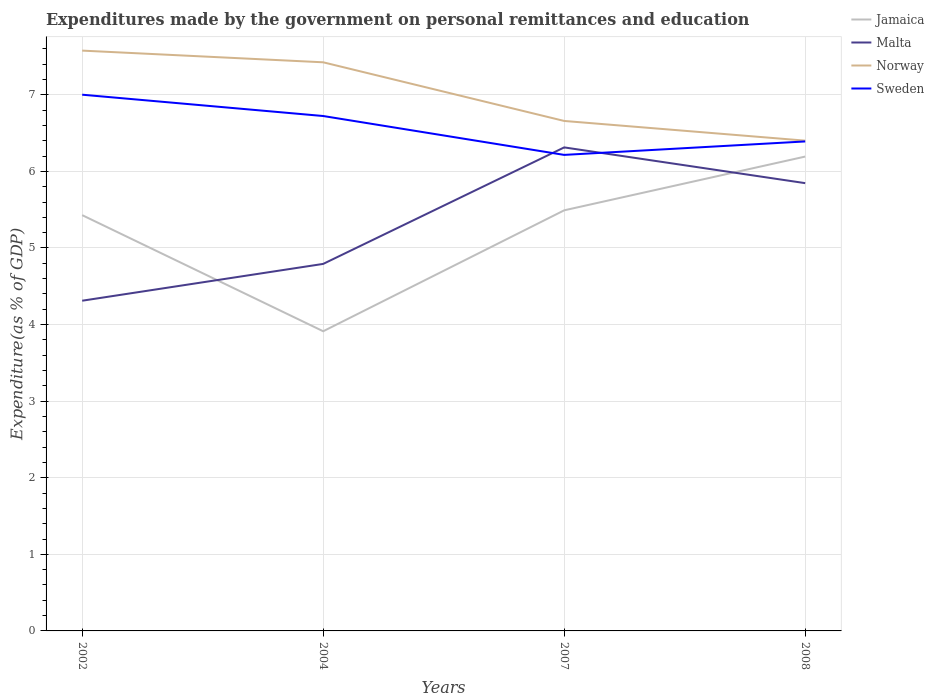Does the line corresponding to Jamaica intersect with the line corresponding to Malta?
Provide a succinct answer. Yes. Is the number of lines equal to the number of legend labels?
Keep it short and to the point. Yes. Across all years, what is the maximum expenditures made by the government on personal remittances and education in Sweden?
Your response must be concise. 6.22. In which year was the expenditures made by the government on personal remittances and education in Sweden maximum?
Ensure brevity in your answer.  2007. What is the total expenditures made by the government on personal remittances and education in Norway in the graph?
Your response must be concise. 0.92. What is the difference between the highest and the second highest expenditures made by the government on personal remittances and education in Norway?
Offer a terse response. 1.18. What is the difference between the highest and the lowest expenditures made by the government on personal remittances and education in Norway?
Offer a very short reply. 2. How many years are there in the graph?
Offer a terse response. 4. Are the values on the major ticks of Y-axis written in scientific E-notation?
Make the answer very short. No. Does the graph contain grids?
Keep it short and to the point. Yes. Where does the legend appear in the graph?
Your answer should be compact. Top right. How many legend labels are there?
Make the answer very short. 4. What is the title of the graph?
Make the answer very short. Expenditures made by the government on personal remittances and education. What is the label or title of the X-axis?
Provide a short and direct response. Years. What is the label or title of the Y-axis?
Your response must be concise. Expenditure(as % of GDP). What is the Expenditure(as % of GDP) in Jamaica in 2002?
Give a very brief answer. 5.43. What is the Expenditure(as % of GDP) of Malta in 2002?
Ensure brevity in your answer.  4.31. What is the Expenditure(as % of GDP) in Norway in 2002?
Provide a succinct answer. 7.58. What is the Expenditure(as % of GDP) in Sweden in 2002?
Make the answer very short. 7. What is the Expenditure(as % of GDP) of Jamaica in 2004?
Give a very brief answer. 3.91. What is the Expenditure(as % of GDP) of Malta in 2004?
Make the answer very short. 4.79. What is the Expenditure(as % of GDP) in Norway in 2004?
Ensure brevity in your answer.  7.42. What is the Expenditure(as % of GDP) in Sweden in 2004?
Your answer should be compact. 6.72. What is the Expenditure(as % of GDP) in Jamaica in 2007?
Provide a succinct answer. 5.49. What is the Expenditure(as % of GDP) in Malta in 2007?
Your response must be concise. 6.31. What is the Expenditure(as % of GDP) of Norway in 2007?
Ensure brevity in your answer.  6.66. What is the Expenditure(as % of GDP) of Sweden in 2007?
Keep it short and to the point. 6.22. What is the Expenditure(as % of GDP) in Jamaica in 2008?
Ensure brevity in your answer.  6.19. What is the Expenditure(as % of GDP) of Malta in 2008?
Offer a very short reply. 5.85. What is the Expenditure(as % of GDP) in Norway in 2008?
Your answer should be compact. 6.4. What is the Expenditure(as % of GDP) in Sweden in 2008?
Your answer should be compact. 6.39. Across all years, what is the maximum Expenditure(as % of GDP) of Jamaica?
Provide a succinct answer. 6.19. Across all years, what is the maximum Expenditure(as % of GDP) of Malta?
Your answer should be very brief. 6.31. Across all years, what is the maximum Expenditure(as % of GDP) of Norway?
Keep it short and to the point. 7.58. Across all years, what is the maximum Expenditure(as % of GDP) in Sweden?
Ensure brevity in your answer.  7. Across all years, what is the minimum Expenditure(as % of GDP) in Jamaica?
Offer a terse response. 3.91. Across all years, what is the minimum Expenditure(as % of GDP) in Malta?
Give a very brief answer. 4.31. Across all years, what is the minimum Expenditure(as % of GDP) in Norway?
Ensure brevity in your answer.  6.4. Across all years, what is the minimum Expenditure(as % of GDP) of Sweden?
Make the answer very short. 6.22. What is the total Expenditure(as % of GDP) of Jamaica in the graph?
Offer a very short reply. 21.03. What is the total Expenditure(as % of GDP) in Malta in the graph?
Make the answer very short. 21.26. What is the total Expenditure(as % of GDP) in Norway in the graph?
Ensure brevity in your answer.  28.06. What is the total Expenditure(as % of GDP) in Sweden in the graph?
Provide a succinct answer. 26.33. What is the difference between the Expenditure(as % of GDP) in Jamaica in 2002 and that in 2004?
Your answer should be very brief. 1.52. What is the difference between the Expenditure(as % of GDP) of Malta in 2002 and that in 2004?
Offer a terse response. -0.48. What is the difference between the Expenditure(as % of GDP) in Norway in 2002 and that in 2004?
Your answer should be compact. 0.15. What is the difference between the Expenditure(as % of GDP) of Sweden in 2002 and that in 2004?
Your answer should be very brief. 0.28. What is the difference between the Expenditure(as % of GDP) in Jamaica in 2002 and that in 2007?
Offer a terse response. -0.06. What is the difference between the Expenditure(as % of GDP) in Malta in 2002 and that in 2007?
Ensure brevity in your answer.  -2. What is the difference between the Expenditure(as % of GDP) in Norway in 2002 and that in 2007?
Keep it short and to the point. 0.92. What is the difference between the Expenditure(as % of GDP) in Sweden in 2002 and that in 2007?
Ensure brevity in your answer.  0.79. What is the difference between the Expenditure(as % of GDP) in Jamaica in 2002 and that in 2008?
Provide a short and direct response. -0.76. What is the difference between the Expenditure(as % of GDP) of Malta in 2002 and that in 2008?
Offer a terse response. -1.53. What is the difference between the Expenditure(as % of GDP) in Norway in 2002 and that in 2008?
Provide a short and direct response. 1.18. What is the difference between the Expenditure(as % of GDP) in Sweden in 2002 and that in 2008?
Make the answer very short. 0.61. What is the difference between the Expenditure(as % of GDP) of Jamaica in 2004 and that in 2007?
Your answer should be compact. -1.58. What is the difference between the Expenditure(as % of GDP) in Malta in 2004 and that in 2007?
Ensure brevity in your answer.  -1.52. What is the difference between the Expenditure(as % of GDP) of Norway in 2004 and that in 2007?
Your response must be concise. 0.77. What is the difference between the Expenditure(as % of GDP) of Sweden in 2004 and that in 2007?
Your answer should be compact. 0.51. What is the difference between the Expenditure(as % of GDP) of Jamaica in 2004 and that in 2008?
Make the answer very short. -2.28. What is the difference between the Expenditure(as % of GDP) of Malta in 2004 and that in 2008?
Keep it short and to the point. -1.05. What is the difference between the Expenditure(as % of GDP) of Sweden in 2004 and that in 2008?
Provide a short and direct response. 0.33. What is the difference between the Expenditure(as % of GDP) in Jamaica in 2007 and that in 2008?
Your answer should be compact. -0.7. What is the difference between the Expenditure(as % of GDP) of Malta in 2007 and that in 2008?
Your answer should be compact. 0.47. What is the difference between the Expenditure(as % of GDP) in Norway in 2007 and that in 2008?
Give a very brief answer. 0.26. What is the difference between the Expenditure(as % of GDP) in Sweden in 2007 and that in 2008?
Ensure brevity in your answer.  -0.18. What is the difference between the Expenditure(as % of GDP) of Jamaica in 2002 and the Expenditure(as % of GDP) of Malta in 2004?
Make the answer very short. 0.64. What is the difference between the Expenditure(as % of GDP) of Jamaica in 2002 and the Expenditure(as % of GDP) of Norway in 2004?
Provide a short and direct response. -2. What is the difference between the Expenditure(as % of GDP) of Jamaica in 2002 and the Expenditure(as % of GDP) of Sweden in 2004?
Offer a very short reply. -1.29. What is the difference between the Expenditure(as % of GDP) in Malta in 2002 and the Expenditure(as % of GDP) in Norway in 2004?
Offer a terse response. -3.11. What is the difference between the Expenditure(as % of GDP) of Malta in 2002 and the Expenditure(as % of GDP) of Sweden in 2004?
Give a very brief answer. -2.41. What is the difference between the Expenditure(as % of GDP) in Norway in 2002 and the Expenditure(as % of GDP) in Sweden in 2004?
Make the answer very short. 0.85. What is the difference between the Expenditure(as % of GDP) of Jamaica in 2002 and the Expenditure(as % of GDP) of Malta in 2007?
Ensure brevity in your answer.  -0.88. What is the difference between the Expenditure(as % of GDP) in Jamaica in 2002 and the Expenditure(as % of GDP) in Norway in 2007?
Offer a very short reply. -1.23. What is the difference between the Expenditure(as % of GDP) of Jamaica in 2002 and the Expenditure(as % of GDP) of Sweden in 2007?
Your answer should be compact. -0.79. What is the difference between the Expenditure(as % of GDP) of Malta in 2002 and the Expenditure(as % of GDP) of Norway in 2007?
Your answer should be very brief. -2.35. What is the difference between the Expenditure(as % of GDP) of Malta in 2002 and the Expenditure(as % of GDP) of Sweden in 2007?
Offer a terse response. -1.9. What is the difference between the Expenditure(as % of GDP) of Norway in 2002 and the Expenditure(as % of GDP) of Sweden in 2007?
Your answer should be compact. 1.36. What is the difference between the Expenditure(as % of GDP) in Jamaica in 2002 and the Expenditure(as % of GDP) in Malta in 2008?
Give a very brief answer. -0.42. What is the difference between the Expenditure(as % of GDP) in Jamaica in 2002 and the Expenditure(as % of GDP) in Norway in 2008?
Your response must be concise. -0.97. What is the difference between the Expenditure(as % of GDP) in Jamaica in 2002 and the Expenditure(as % of GDP) in Sweden in 2008?
Offer a terse response. -0.96. What is the difference between the Expenditure(as % of GDP) in Malta in 2002 and the Expenditure(as % of GDP) in Norway in 2008?
Offer a very short reply. -2.09. What is the difference between the Expenditure(as % of GDP) in Malta in 2002 and the Expenditure(as % of GDP) in Sweden in 2008?
Offer a terse response. -2.08. What is the difference between the Expenditure(as % of GDP) in Norway in 2002 and the Expenditure(as % of GDP) in Sweden in 2008?
Give a very brief answer. 1.19. What is the difference between the Expenditure(as % of GDP) in Jamaica in 2004 and the Expenditure(as % of GDP) in Malta in 2007?
Give a very brief answer. -2.4. What is the difference between the Expenditure(as % of GDP) of Jamaica in 2004 and the Expenditure(as % of GDP) of Norway in 2007?
Keep it short and to the point. -2.75. What is the difference between the Expenditure(as % of GDP) in Jamaica in 2004 and the Expenditure(as % of GDP) in Sweden in 2007?
Your response must be concise. -2.3. What is the difference between the Expenditure(as % of GDP) of Malta in 2004 and the Expenditure(as % of GDP) of Norway in 2007?
Your answer should be compact. -1.87. What is the difference between the Expenditure(as % of GDP) of Malta in 2004 and the Expenditure(as % of GDP) of Sweden in 2007?
Ensure brevity in your answer.  -1.42. What is the difference between the Expenditure(as % of GDP) in Norway in 2004 and the Expenditure(as % of GDP) in Sweden in 2007?
Offer a terse response. 1.21. What is the difference between the Expenditure(as % of GDP) of Jamaica in 2004 and the Expenditure(as % of GDP) of Malta in 2008?
Make the answer very short. -1.93. What is the difference between the Expenditure(as % of GDP) of Jamaica in 2004 and the Expenditure(as % of GDP) of Norway in 2008?
Provide a short and direct response. -2.49. What is the difference between the Expenditure(as % of GDP) of Jamaica in 2004 and the Expenditure(as % of GDP) of Sweden in 2008?
Offer a terse response. -2.48. What is the difference between the Expenditure(as % of GDP) of Malta in 2004 and the Expenditure(as % of GDP) of Norway in 2008?
Provide a succinct answer. -1.61. What is the difference between the Expenditure(as % of GDP) of Malta in 2004 and the Expenditure(as % of GDP) of Sweden in 2008?
Your answer should be very brief. -1.6. What is the difference between the Expenditure(as % of GDP) of Jamaica in 2007 and the Expenditure(as % of GDP) of Malta in 2008?
Your answer should be very brief. -0.35. What is the difference between the Expenditure(as % of GDP) of Jamaica in 2007 and the Expenditure(as % of GDP) of Norway in 2008?
Make the answer very short. -0.91. What is the difference between the Expenditure(as % of GDP) in Jamaica in 2007 and the Expenditure(as % of GDP) in Sweden in 2008?
Make the answer very short. -0.9. What is the difference between the Expenditure(as % of GDP) in Malta in 2007 and the Expenditure(as % of GDP) in Norway in 2008?
Keep it short and to the point. -0.09. What is the difference between the Expenditure(as % of GDP) of Malta in 2007 and the Expenditure(as % of GDP) of Sweden in 2008?
Offer a very short reply. -0.08. What is the difference between the Expenditure(as % of GDP) of Norway in 2007 and the Expenditure(as % of GDP) of Sweden in 2008?
Make the answer very short. 0.27. What is the average Expenditure(as % of GDP) of Jamaica per year?
Give a very brief answer. 5.26. What is the average Expenditure(as % of GDP) in Malta per year?
Provide a short and direct response. 5.32. What is the average Expenditure(as % of GDP) of Norway per year?
Your answer should be very brief. 7.01. What is the average Expenditure(as % of GDP) of Sweden per year?
Your answer should be compact. 6.58. In the year 2002, what is the difference between the Expenditure(as % of GDP) of Jamaica and Expenditure(as % of GDP) of Malta?
Keep it short and to the point. 1.12. In the year 2002, what is the difference between the Expenditure(as % of GDP) in Jamaica and Expenditure(as % of GDP) in Norway?
Offer a very short reply. -2.15. In the year 2002, what is the difference between the Expenditure(as % of GDP) in Jamaica and Expenditure(as % of GDP) in Sweden?
Your answer should be very brief. -1.57. In the year 2002, what is the difference between the Expenditure(as % of GDP) in Malta and Expenditure(as % of GDP) in Norway?
Your response must be concise. -3.27. In the year 2002, what is the difference between the Expenditure(as % of GDP) of Malta and Expenditure(as % of GDP) of Sweden?
Ensure brevity in your answer.  -2.69. In the year 2002, what is the difference between the Expenditure(as % of GDP) in Norway and Expenditure(as % of GDP) in Sweden?
Offer a terse response. 0.58. In the year 2004, what is the difference between the Expenditure(as % of GDP) in Jamaica and Expenditure(as % of GDP) in Malta?
Give a very brief answer. -0.88. In the year 2004, what is the difference between the Expenditure(as % of GDP) in Jamaica and Expenditure(as % of GDP) in Norway?
Your answer should be compact. -3.51. In the year 2004, what is the difference between the Expenditure(as % of GDP) of Jamaica and Expenditure(as % of GDP) of Sweden?
Make the answer very short. -2.81. In the year 2004, what is the difference between the Expenditure(as % of GDP) of Malta and Expenditure(as % of GDP) of Norway?
Your answer should be very brief. -2.63. In the year 2004, what is the difference between the Expenditure(as % of GDP) of Malta and Expenditure(as % of GDP) of Sweden?
Provide a short and direct response. -1.93. In the year 2004, what is the difference between the Expenditure(as % of GDP) in Norway and Expenditure(as % of GDP) in Sweden?
Keep it short and to the point. 0.7. In the year 2007, what is the difference between the Expenditure(as % of GDP) in Jamaica and Expenditure(as % of GDP) in Malta?
Keep it short and to the point. -0.82. In the year 2007, what is the difference between the Expenditure(as % of GDP) of Jamaica and Expenditure(as % of GDP) of Norway?
Your response must be concise. -1.17. In the year 2007, what is the difference between the Expenditure(as % of GDP) of Jamaica and Expenditure(as % of GDP) of Sweden?
Give a very brief answer. -0.72. In the year 2007, what is the difference between the Expenditure(as % of GDP) of Malta and Expenditure(as % of GDP) of Norway?
Your answer should be very brief. -0.35. In the year 2007, what is the difference between the Expenditure(as % of GDP) of Malta and Expenditure(as % of GDP) of Sweden?
Offer a very short reply. 0.1. In the year 2007, what is the difference between the Expenditure(as % of GDP) of Norway and Expenditure(as % of GDP) of Sweden?
Provide a succinct answer. 0.44. In the year 2008, what is the difference between the Expenditure(as % of GDP) in Jamaica and Expenditure(as % of GDP) in Malta?
Provide a succinct answer. 0.35. In the year 2008, what is the difference between the Expenditure(as % of GDP) in Jamaica and Expenditure(as % of GDP) in Norway?
Ensure brevity in your answer.  -0.21. In the year 2008, what is the difference between the Expenditure(as % of GDP) in Jamaica and Expenditure(as % of GDP) in Sweden?
Keep it short and to the point. -0.2. In the year 2008, what is the difference between the Expenditure(as % of GDP) in Malta and Expenditure(as % of GDP) in Norway?
Provide a succinct answer. -0.55. In the year 2008, what is the difference between the Expenditure(as % of GDP) in Malta and Expenditure(as % of GDP) in Sweden?
Your answer should be compact. -0.54. In the year 2008, what is the difference between the Expenditure(as % of GDP) in Norway and Expenditure(as % of GDP) in Sweden?
Offer a very short reply. 0.01. What is the ratio of the Expenditure(as % of GDP) of Jamaica in 2002 to that in 2004?
Provide a short and direct response. 1.39. What is the ratio of the Expenditure(as % of GDP) of Malta in 2002 to that in 2004?
Your answer should be very brief. 0.9. What is the ratio of the Expenditure(as % of GDP) of Norway in 2002 to that in 2004?
Make the answer very short. 1.02. What is the ratio of the Expenditure(as % of GDP) in Sweden in 2002 to that in 2004?
Your answer should be very brief. 1.04. What is the ratio of the Expenditure(as % of GDP) in Jamaica in 2002 to that in 2007?
Provide a short and direct response. 0.99. What is the ratio of the Expenditure(as % of GDP) of Malta in 2002 to that in 2007?
Offer a very short reply. 0.68. What is the ratio of the Expenditure(as % of GDP) in Norway in 2002 to that in 2007?
Your answer should be compact. 1.14. What is the ratio of the Expenditure(as % of GDP) of Sweden in 2002 to that in 2007?
Provide a succinct answer. 1.13. What is the ratio of the Expenditure(as % of GDP) in Jamaica in 2002 to that in 2008?
Provide a short and direct response. 0.88. What is the ratio of the Expenditure(as % of GDP) in Malta in 2002 to that in 2008?
Your answer should be very brief. 0.74. What is the ratio of the Expenditure(as % of GDP) of Norway in 2002 to that in 2008?
Your response must be concise. 1.18. What is the ratio of the Expenditure(as % of GDP) in Sweden in 2002 to that in 2008?
Provide a succinct answer. 1.1. What is the ratio of the Expenditure(as % of GDP) in Jamaica in 2004 to that in 2007?
Ensure brevity in your answer.  0.71. What is the ratio of the Expenditure(as % of GDP) of Malta in 2004 to that in 2007?
Make the answer very short. 0.76. What is the ratio of the Expenditure(as % of GDP) in Norway in 2004 to that in 2007?
Your response must be concise. 1.11. What is the ratio of the Expenditure(as % of GDP) of Sweden in 2004 to that in 2007?
Ensure brevity in your answer.  1.08. What is the ratio of the Expenditure(as % of GDP) of Jamaica in 2004 to that in 2008?
Offer a terse response. 0.63. What is the ratio of the Expenditure(as % of GDP) of Malta in 2004 to that in 2008?
Offer a terse response. 0.82. What is the ratio of the Expenditure(as % of GDP) of Norway in 2004 to that in 2008?
Your response must be concise. 1.16. What is the ratio of the Expenditure(as % of GDP) in Sweden in 2004 to that in 2008?
Provide a short and direct response. 1.05. What is the ratio of the Expenditure(as % of GDP) of Jamaica in 2007 to that in 2008?
Your answer should be compact. 0.89. What is the ratio of the Expenditure(as % of GDP) in Malta in 2007 to that in 2008?
Provide a succinct answer. 1.08. What is the ratio of the Expenditure(as % of GDP) of Norway in 2007 to that in 2008?
Your response must be concise. 1.04. What is the ratio of the Expenditure(as % of GDP) of Sweden in 2007 to that in 2008?
Provide a short and direct response. 0.97. What is the difference between the highest and the second highest Expenditure(as % of GDP) in Jamaica?
Give a very brief answer. 0.7. What is the difference between the highest and the second highest Expenditure(as % of GDP) in Malta?
Ensure brevity in your answer.  0.47. What is the difference between the highest and the second highest Expenditure(as % of GDP) in Norway?
Keep it short and to the point. 0.15. What is the difference between the highest and the second highest Expenditure(as % of GDP) in Sweden?
Keep it short and to the point. 0.28. What is the difference between the highest and the lowest Expenditure(as % of GDP) of Jamaica?
Give a very brief answer. 2.28. What is the difference between the highest and the lowest Expenditure(as % of GDP) in Malta?
Provide a short and direct response. 2. What is the difference between the highest and the lowest Expenditure(as % of GDP) of Norway?
Give a very brief answer. 1.18. What is the difference between the highest and the lowest Expenditure(as % of GDP) of Sweden?
Provide a short and direct response. 0.79. 